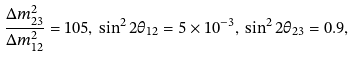<formula> <loc_0><loc_0><loc_500><loc_500>\frac { \Delta m _ { 2 3 } ^ { 2 } } { \Delta m _ { 1 2 } ^ { 2 } } = 1 0 5 , \, { \sin ^ { 2 } 2 \theta _ { 1 2 } } = 5 \times 1 0 ^ { - 3 } , \, { \sin ^ { 2 } 2 \theta _ { 2 3 } } = 0 . 9 ,</formula> 